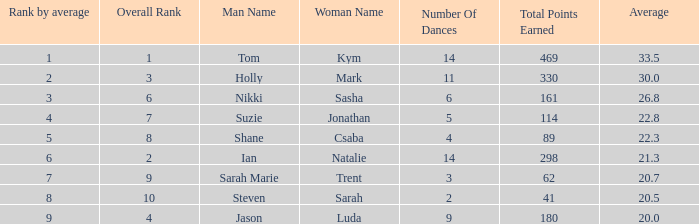What is the total points earned total number if the average is 21.3? 1.0. 